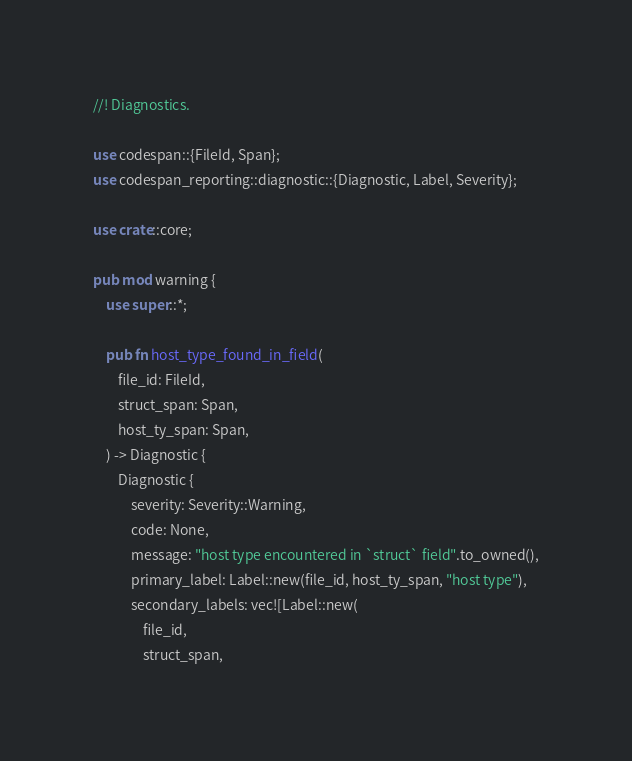<code> <loc_0><loc_0><loc_500><loc_500><_Rust_>//! Diagnostics.

use codespan::{FileId, Span};
use codespan_reporting::diagnostic::{Diagnostic, Label, Severity};

use crate::core;

pub mod warning {
    use super::*;

    pub fn host_type_found_in_field(
        file_id: FileId,
        struct_span: Span,
        host_ty_span: Span,
    ) -> Diagnostic {
        Diagnostic {
            severity: Severity::Warning,
            code: None,
            message: "host type encountered in `struct` field".to_owned(),
            primary_label: Label::new(file_id, host_ty_span, "host type"),
            secondary_labels: vec![Label::new(
                file_id,
                struct_span,</code> 